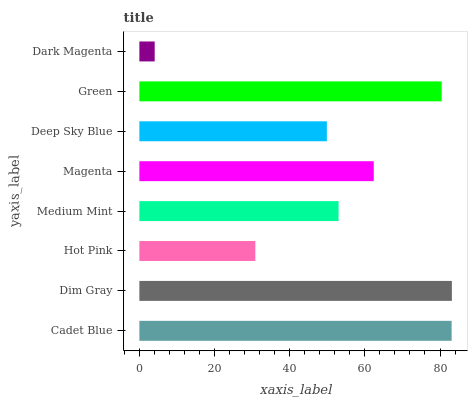Is Dark Magenta the minimum?
Answer yes or no. Yes. Is Dim Gray the maximum?
Answer yes or no. Yes. Is Hot Pink the minimum?
Answer yes or no. No. Is Hot Pink the maximum?
Answer yes or no. No. Is Dim Gray greater than Hot Pink?
Answer yes or no. Yes. Is Hot Pink less than Dim Gray?
Answer yes or no. Yes. Is Hot Pink greater than Dim Gray?
Answer yes or no. No. Is Dim Gray less than Hot Pink?
Answer yes or no. No. Is Magenta the high median?
Answer yes or no. Yes. Is Medium Mint the low median?
Answer yes or no. Yes. Is Medium Mint the high median?
Answer yes or no. No. Is Green the low median?
Answer yes or no. No. 